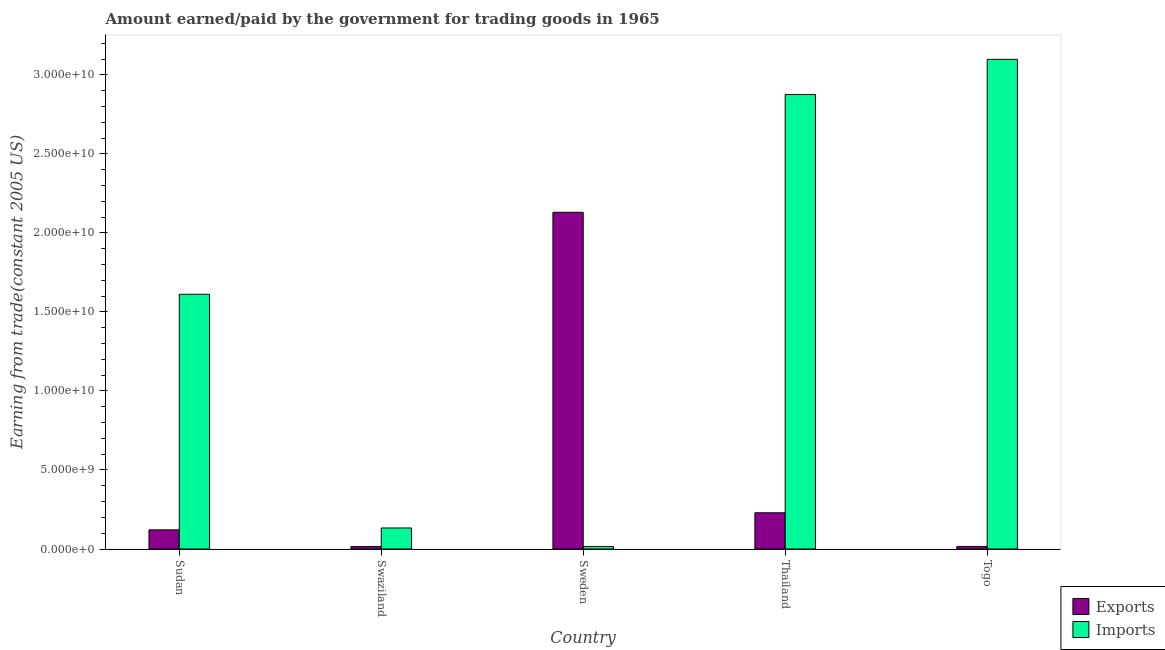How many groups of bars are there?
Offer a terse response. 5. Are the number of bars on each tick of the X-axis equal?
Provide a short and direct response. Yes. How many bars are there on the 5th tick from the left?
Provide a succinct answer. 2. What is the label of the 2nd group of bars from the left?
Make the answer very short. Swaziland. In how many cases, is the number of bars for a given country not equal to the number of legend labels?
Your response must be concise. 0. What is the amount earned from exports in Togo?
Your answer should be very brief. 1.62e+08. Across all countries, what is the maximum amount earned from exports?
Your answer should be compact. 2.13e+1. Across all countries, what is the minimum amount paid for imports?
Your response must be concise. 1.60e+08. In which country was the amount paid for imports maximum?
Offer a terse response. Togo. What is the total amount earned from exports in the graph?
Provide a short and direct response. 2.51e+1. What is the difference between the amount earned from exports in Sudan and that in Swaziland?
Provide a short and direct response. 1.05e+09. What is the difference between the amount paid for imports in Sudan and the amount earned from exports in Thailand?
Ensure brevity in your answer.  1.38e+1. What is the average amount paid for imports per country?
Your response must be concise. 1.55e+1. What is the difference between the amount paid for imports and amount earned from exports in Sweden?
Keep it short and to the point. -2.11e+1. What is the ratio of the amount paid for imports in Sweden to that in Thailand?
Your answer should be very brief. 0.01. Is the difference between the amount earned from exports in Sudan and Togo greater than the difference between the amount paid for imports in Sudan and Togo?
Your response must be concise. Yes. What is the difference between the highest and the second highest amount earned from exports?
Keep it short and to the point. 1.90e+1. What is the difference between the highest and the lowest amount paid for imports?
Give a very brief answer. 3.08e+1. In how many countries, is the amount paid for imports greater than the average amount paid for imports taken over all countries?
Give a very brief answer. 3. Is the sum of the amount earned from exports in Sudan and Swaziland greater than the maximum amount paid for imports across all countries?
Make the answer very short. No. What does the 2nd bar from the left in Swaziland represents?
Make the answer very short. Imports. What does the 1st bar from the right in Swaziland represents?
Ensure brevity in your answer.  Imports. How many bars are there?
Make the answer very short. 10. Are all the bars in the graph horizontal?
Your answer should be compact. No. What is the difference between two consecutive major ticks on the Y-axis?
Make the answer very short. 5.00e+09. Are the values on the major ticks of Y-axis written in scientific E-notation?
Offer a very short reply. Yes. Does the graph contain any zero values?
Your response must be concise. No. Does the graph contain grids?
Provide a short and direct response. No. How many legend labels are there?
Your answer should be very brief. 2. What is the title of the graph?
Your response must be concise. Amount earned/paid by the government for trading goods in 1965. Does "International Visitors" appear as one of the legend labels in the graph?
Give a very brief answer. No. What is the label or title of the Y-axis?
Provide a short and direct response. Earning from trade(constant 2005 US). What is the Earning from trade(constant 2005 US) in Exports in Sudan?
Your response must be concise. 1.21e+09. What is the Earning from trade(constant 2005 US) of Imports in Sudan?
Offer a very short reply. 1.61e+1. What is the Earning from trade(constant 2005 US) in Exports in Swaziland?
Offer a very short reply. 1.57e+08. What is the Earning from trade(constant 2005 US) in Imports in Swaziland?
Give a very brief answer. 1.33e+09. What is the Earning from trade(constant 2005 US) in Exports in Sweden?
Ensure brevity in your answer.  2.13e+1. What is the Earning from trade(constant 2005 US) in Imports in Sweden?
Make the answer very short. 1.60e+08. What is the Earning from trade(constant 2005 US) of Exports in Thailand?
Your response must be concise. 2.29e+09. What is the Earning from trade(constant 2005 US) of Imports in Thailand?
Your answer should be compact. 2.88e+1. What is the Earning from trade(constant 2005 US) in Exports in Togo?
Your answer should be very brief. 1.62e+08. What is the Earning from trade(constant 2005 US) in Imports in Togo?
Your answer should be very brief. 3.10e+1. Across all countries, what is the maximum Earning from trade(constant 2005 US) in Exports?
Provide a succinct answer. 2.13e+1. Across all countries, what is the maximum Earning from trade(constant 2005 US) in Imports?
Your answer should be compact. 3.10e+1. Across all countries, what is the minimum Earning from trade(constant 2005 US) in Exports?
Keep it short and to the point. 1.57e+08. Across all countries, what is the minimum Earning from trade(constant 2005 US) in Imports?
Your response must be concise. 1.60e+08. What is the total Earning from trade(constant 2005 US) of Exports in the graph?
Your answer should be compact. 2.51e+1. What is the total Earning from trade(constant 2005 US) in Imports in the graph?
Give a very brief answer. 7.73e+1. What is the difference between the Earning from trade(constant 2005 US) of Exports in Sudan and that in Swaziland?
Keep it short and to the point. 1.05e+09. What is the difference between the Earning from trade(constant 2005 US) of Imports in Sudan and that in Swaziland?
Make the answer very short. 1.48e+1. What is the difference between the Earning from trade(constant 2005 US) of Exports in Sudan and that in Sweden?
Give a very brief answer. -2.01e+1. What is the difference between the Earning from trade(constant 2005 US) of Imports in Sudan and that in Sweden?
Give a very brief answer. 1.60e+1. What is the difference between the Earning from trade(constant 2005 US) of Exports in Sudan and that in Thailand?
Offer a very short reply. -1.08e+09. What is the difference between the Earning from trade(constant 2005 US) of Imports in Sudan and that in Thailand?
Your answer should be very brief. -1.26e+1. What is the difference between the Earning from trade(constant 2005 US) in Exports in Sudan and that in Togo?
Ensure brevity in your answer.  1.05e+09. What is the difference between the Earning from trade(constant 2005 US) in Imports in Sudan and that in Togo?
Offer a terse response. -1.49e+1. What is the difference between the Earning from trade(constant 2005 US) in Exports in Swaziland and that in Sweden?
Ensure brevity in your answer.  -2.11e+1. What is the difference between the Earning from trade(constant 2005 US) in Imports in Swaziland and that in Sweden?
Your response must be concise. 1.17e+09. What is the difference between the Earning from trade(constant 2005 US) in Exports in Swaziland and that in Thailand?
Make the answer very short. -2.14e+09. What is the difference between the Earning from trade(constant 2005 US) in Imports in Swaziland and that in Thailand?
Your answer should be compact. -2.74e+1. What is the difference between the Earning from trade(constant 2005 US) in Exports in Swaziland and that in Togo?
Make the answer very short. -4.61e+06. What is the difference between the Earning from trade(constant 2005 US) in Imports in Swaziland and that in Togo?
Provide a succinct answer. -2.97e+1. What is the difference between the Earning from trade(constant 2005 US) of Exports in Sweden and that in Thailand?
Offer a terse response. 1.90e+1. What is the difference between the Earning from trade(constant 2005 US) in Imports in Sweden and that in Thailand?
Your answer should be compact. -2.86e+1. What is the difference between the Earning from trade(constant 2005 US) of Exports in Sweden and that in Togo?
Offer a terse response. 2.11e+1. What is the difference between the Earning from trade(constant 2005 US) in Imports in Sweden and that in Togo?
Provide a succinct answer. -3.08e+1. What is the difference between the Earning from trade(constant 2005 US) in Exports in Thailand and that in Togo?
Ensure brevity in your answer.  2.13e+09. What is the difference between the Earning from trade(constant 2005 US) of Imports in Thailand and that in Togo?
Keep it short and to the point. -2.22e+09. What is the difference between the Earning from trade(constant 2005 US) in Exports in Sudan and the Earning from trade(constant 2005 US) in Imports in Swaziland?
Your answer should be compact. -1.19e+08. What is the difference between the Earning from trade(constant 2005 US) of Exports in Sudan and the Earning from trade(constant 2005 US) of Imports in Sweden?
Provide a short and direct response. 1.05e+09. What is the difference between the Earning from trade(constant 2005 US) of Exports in Sudan and the Earning from trade(constant 2005 US) of Imports in Thailand?
Make the answer very short. -2.75e+1. What is the difference between the Earning from trade(constant 2005 US) in Exports in Sudan and the Earning from trade(constant 2005 US) in Imports in Togo?
Provide a succinct answer. -2.98e+1. What is the difference between the Earning from trade(constant 2005 US) in Exports in Swaziland and the Earning from trade(constant 2005 US) in Imports in Sweden?
Give a very brief answer. -2.47e+06. What is the difference between the Earning from trade(constant 2005 US) in Exports in Swaziland and the Earning from trade(constant 2005 US) in Imports in Thailand?
Ensure brevity in your answer.  -2.86e+1. What is the difference between the Earning from trade(constant 2005 US) of Exports in Swaziland and the Earning from trade(constant 2005 US) of Imports in Togo?
Keep it short and to the point. -3.08e+1. What is the difference between the Earning from trade(constant 2005 US) in Exports in Sweden and the Earning from trade(constant 2005 US) in Imports in Thailand?
Make the answer very short. -7.46e+09. What is the difference between the Earning from trade(constant 2005 US) in Exports in Sweden and the Earning from trade(constant 2005 US) in Imports in Togo?
Offer a terse response. -9.68e+09. What is the difference between the Earning from trade(constant 2005 US) of Exports in Thailand and the Earning from trade(constant 2005 US) of Imports in Togo?
Ensure brevity in your answer.  -2.87e+1. What is the average Earning from trade(constant 2005 US) of Exports per country?
Your response must be concise. 5.03e+09. What is the average Earning from trade(constant 2005 US) in Imports per country?
Keep it short and to the point. 1.55e+1. What is the difference between the Earning from trade(constant 2005 US) in Exports and Earning from trade(constant 2005 US) in Imports in Sudan?
Provide a short and direct response. -1.49e+1. What is the difference between the Earning from trade(constant 2005 US) in Exports and Earning from trade(constant 2005 US) in Imports in Swaziland?
Make the answer very short. -1.17e+09. What is the difference between the Earning from trade(constant 2005 US) of Exports and Earning from trade(constant 2005 US) of Imports in Sweden?
Give a very brief answer. 2.11e+1. What is the difference between the Earning from trade(constant 2005 US) in Exports and Earning from trade(constant 2005 US) in Imports in Thailand?
Your answer should be compact. -2.65e+1. What is the difference between the Earning from trade(constant 2005 US) in Exports and Earning from trade(constant 2005 US) in Imports in Togo?
Your response must be concise. -3.08e+1. What is the ratio of the Earning from trade(constant 2005 US) in Exports in Sudan to that in Swaziland?
Provide a succinct answer. 7.7. What is the ratio of the Earning from trade(constant 2005 US) in Imports in Sudan to that in Swaziland?
Ensure brevity in your answer.  12.12. What is the ratio of the Earning from trade(constant 2005 US) of Exports in Sudan to that in Sweden?
Provide a succinct answer. 0.06. What is the ratio of the Earning from trade(constant 2005 US) in Imports in Sudan to that in Sweden?
Provide a short and direct response. 100.92. What is the ratio of the Earning from trade(constant 2005 US) in Exports in Sudan to that in Thailand?
Offer a very short reply. 0.53. What is the ratio of the Earning from trade(constant 2005 US) of Imports in Sudan to that in Thailand?
Your answer should be compact. 0.56. What is the ratio of the Earning from trade(constant 2005 US) of Exports in Sudan to that in Togo?
Your answer should be compact. 7.48. What is the ratio of the Earning from trade(constant 2005 US) of Imports in Sudan to that in Togo?
Make the answer very short. 0.52. What is the ratio of the Earning from trade(constant 2005 US) of Exports in Swaziland to that in Sweden?
Keep it short and to the point. 0.01. What is the ratio of the Earning from trade(constant 2005 US) of Imports in Swaziland to that in Sweden?
Offer a very short reply. 8.33. What is the ratio of the Earning from trade(constant 2005 US) in Exports in Swaziland to that in Thailand?
Keep it short and to the point. 0.07. What is the ratio of the Earning from trade(constant 2005 US) in Imports in Swaziland to that in Thailand?
Your answer should be very brief. 0.05. What is the ratio of the Earning from trade(constant 2005 US) in Exports in Swaziland to that in Togo?
Your response must be concise. 0.97. What is the ratio of the Earning from trade(constant 2005 US) of Imports in Swaziland to that in Togo?
Ensure brevity in your answer.  0.04. What is the ratio of the Earning from trade(constant 2005 US) in Exports in Sweden to that in Thailand?
Ensure brevity in your answer.  9.29. What is the ratio of the Earning from trade(constant 2005 US) of Imports in Sweden to that in Thailand?
Provide a succinct answer. 0.01. What is the ratio of the Earning from trade(constant 2005 US) of Exports in Sweden to that in Togo?
Provide a short and direct response. 131.63. What is the ratio of the Earning from trade(constant 2005 US) of Imports in Sweden to that in Togo?
Your answer should be compact. 0.01. What is the ratio of the Earning from trade(constant 2005 US) of Exports in Thailand to that in Togo?
Your answer should be compact. 14.17. What is the ratio of the Earning from trade(constant 2005 US) in Imports in Thailand to that in Togo?
Provide a short and direct response. 0.93. What is the difference between the highest and the second highest Earning from trade(constant 2005 US) in Exports?
Give a very brief answer. 1.90e+1. What is the difference between the highest and the second highest Earning from trade(constant 2005 US) in Imports?
Give a very brief answer. 2.22e+09. What is the difference between the highest and the lowest Earning from trade(constant 2005 US) in Exports?
Give a very brief answer. 2.11e+1. What is the difference between the highest and the lowest Earning from trade(constant 2005 US) in Imports?
Provide a succinct answer. 3.08e+1. 